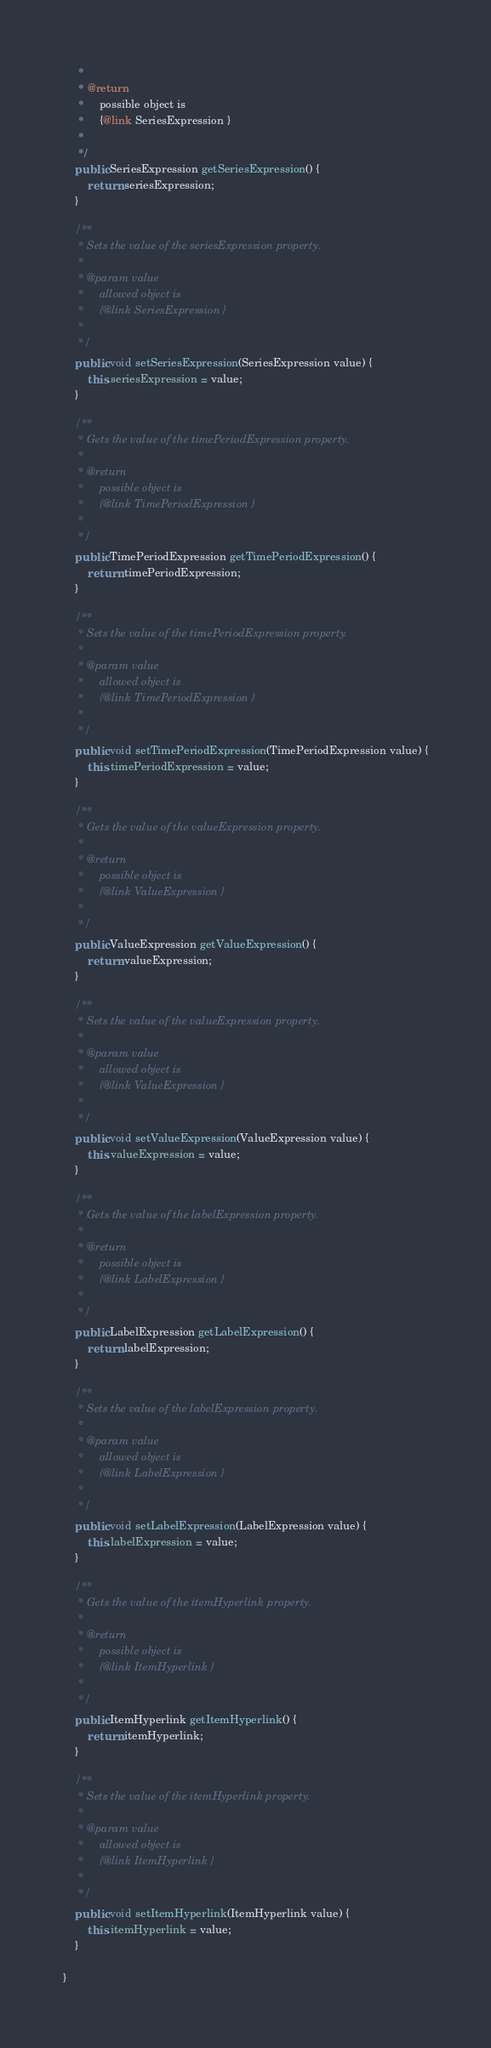Convert code to text. <code><loc_0><loc_0><loc_500><loc_500><_Java_>     * 
     * @return
     *     possible object is
     *     {@link SeriesExpression }
     *     
     */
    public SeriesExpression getSeriesExpression() {
        return seriesExpression;
    }

    /**
     * Sets the value of the seriesExpression property.
     * 
     * @param value
     *     allowed object is
     *     {@link SeriesExpression }
     *     
     */
    public void setSeriesExpression(SeriesExpression value) {
        this.seriesExpression = value;
    }

    /**
     * Gets the value of the timePeriodExpression property.
     * 
     * @return
     *     possible object is
     *     {@link TimePeriodExpression }
     *     
     */
    public TimePeriodExpression getTimePeriodExpression() {
        return timePeriodExpression;
    }

    /**
     * Sets the value of the timePeriodExpression property.
     * 
     * @param value
     *     allowed object is
     *     {@link TimePeriodExpression }
     *     
     */
    public void setTimePeriodExpression(TimePeriodExpression value) {
        this.timePeriodExpression = value;
    }

    /**
     * Gets the value of the valueExpression property.
     * 
     * @return
     *     possible object is
     *     {@link ValueExpression }
     *     
     */
    public ValueExpression getValueExpression() {
        return valueExpression;
    }

    /**
     * Sets the value of the valueExpression property.
     * 
     * @param value
     *     allowed object is
     *     {@link ValueExpression }
     *     
     */
    public void setValueExpression(ValueExpression value) {
        this.valueExpression = value;
    }

    /**
     * Gets the value of the labelExpression property.
     * 
     * @return
     *     possible object is
     *     {@link LabelExpression }
     *     
     */
    public LabelExpression getLabelExpression() {
        return labelExpression;
    }

    /**
     * Sets the value of the labelExpression property.
     * 
     * @param value
     *     allowed object is
     *     {@link LabelExpression }
     *     
     */
    public void setLabelExpression(LabelExpression value) {
        this.labelExpression = value;
    }

    /**
     * Gets the value of the itemHyperlink property.
     * 
     * @return
     *     possible object is
     *     {@link ItemHyperlink }
     *     
     */
    public ItemHyperlink getItemHyperlink() {
        return itemHyperlink;
    }

    /**
     * Sets the value of the itemHyperlink property.
     * 
     * @param value
     *     allowed object is
     *     {@link ItemHyperlink }
     *     
     */
    public void setItemHyperlink(ItemHyperlink value) {
        this.itemHyperlink = value;
    }

}
</code> 